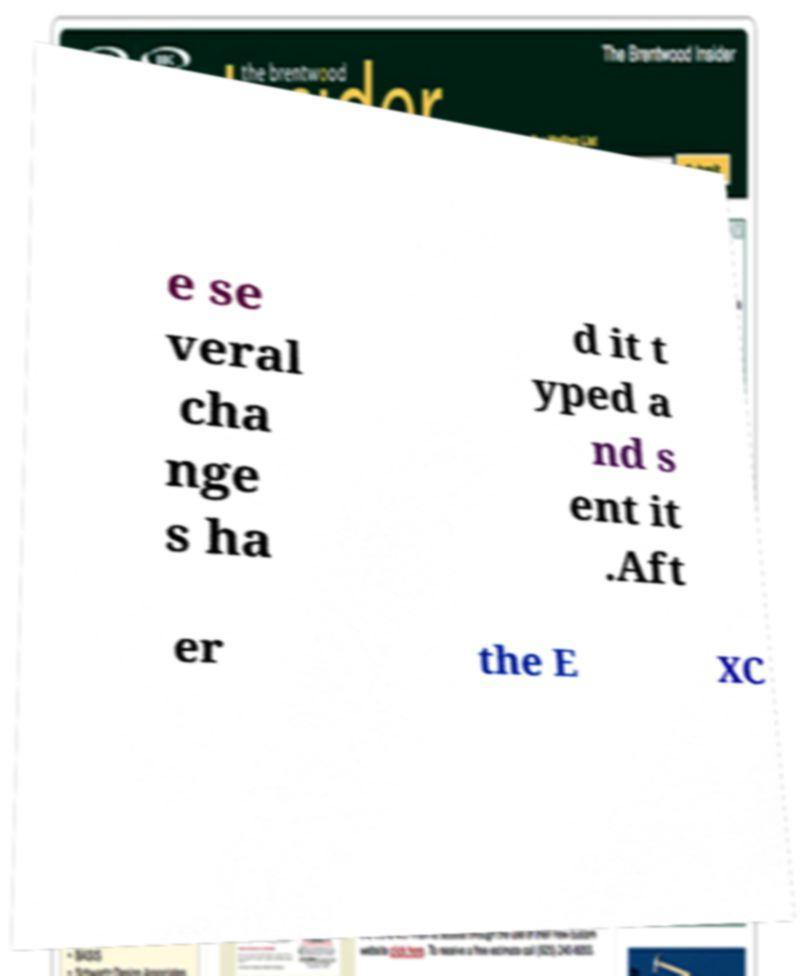What messages or text are displayed in this image? I need them in a readable, typed format. e se veral cha nge s ha d it t yped a nd s ent it .Aft er the E XC 